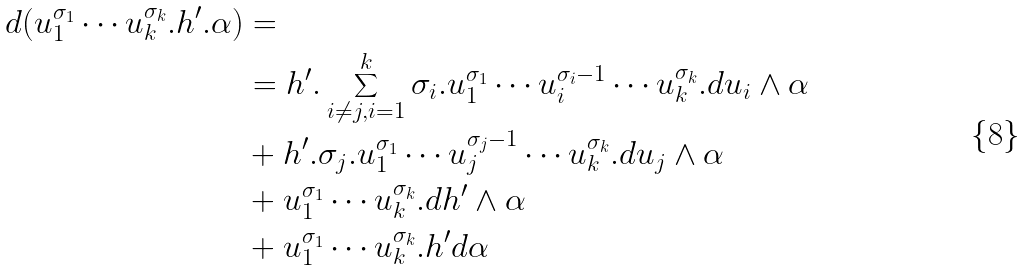<formula> <loc_0><loc_0><loc_500><loc_500>d ( u _ { 1 } ^ { \sigma _ { 1 } } \cdots u _ { k } ^ { \sigma _ { k } } . h ^ { \prime } . \alpha ) & = \\ \quad & = h ^ { \prime } . \sum _ { i \not = j , i = 1 } ^ { k } \sigma _ { i } . u _ { 1 } ^ { \sigma _ { 1 } } \cdots u _ { i } ^ { \sigma _ { i } - 1 } \cdots u _ { k } ^ { \sigma _ { k } } . d u _ { i } \wedge \alpha \\ \quad & + h ^ { \prime } . \sigma _ { j } . u _ { 1 } ^ { \sigma _ { 1 } } \cdots u _ { j } ^ { \sigma _ { j } - 1 } \cdots u _ { k } ^ { \sigma _ { k } } . d u _ { j } \wedge \alpha \\ \quad & + u _ { 1 } ^ { \sigma _ { 1 } } \cdots u _ { k } ^ { \sigma _ { k } } . d h ^ { \prime } \wedge \alpha \\ \quad & + u _ { 1 } ^ { \sigma _ { 1 } } \cdots u _ { k } ^ { \sigma _ { k } } . h ^ { \prime } d \alpha</formula> 